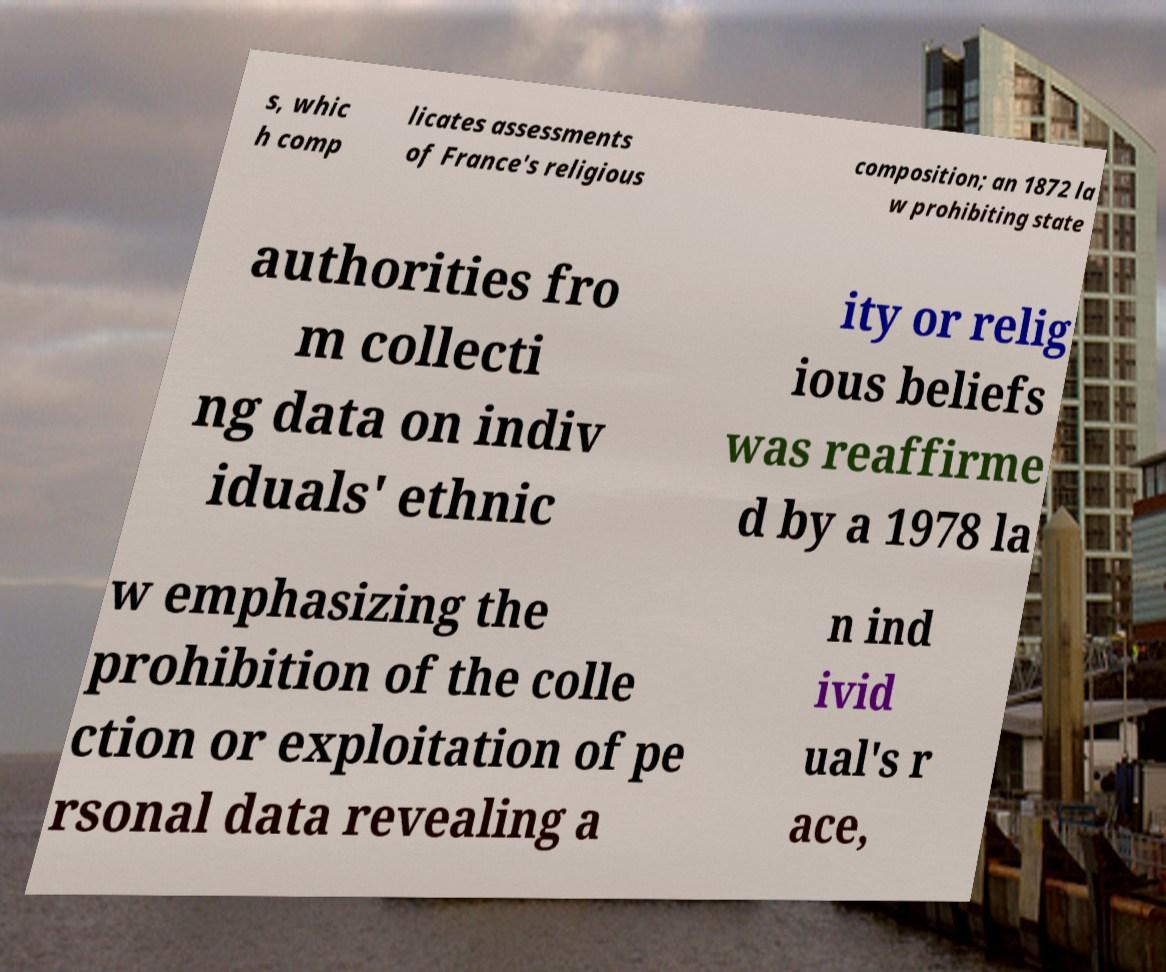Please identify and transcribe the text found in this image. s, whic h comp licates assessments of France's religious composition; an 1872 la w prohibiting state authorities fro m collecti ng data on indiv iduals' ethnic ity or relig ious beliefs was reaffirme d by a 1978 la w emphasizing the prohibition of the colle ction or exploitation of pe rsonal data revealing a n ind ivid ual's r ace, 